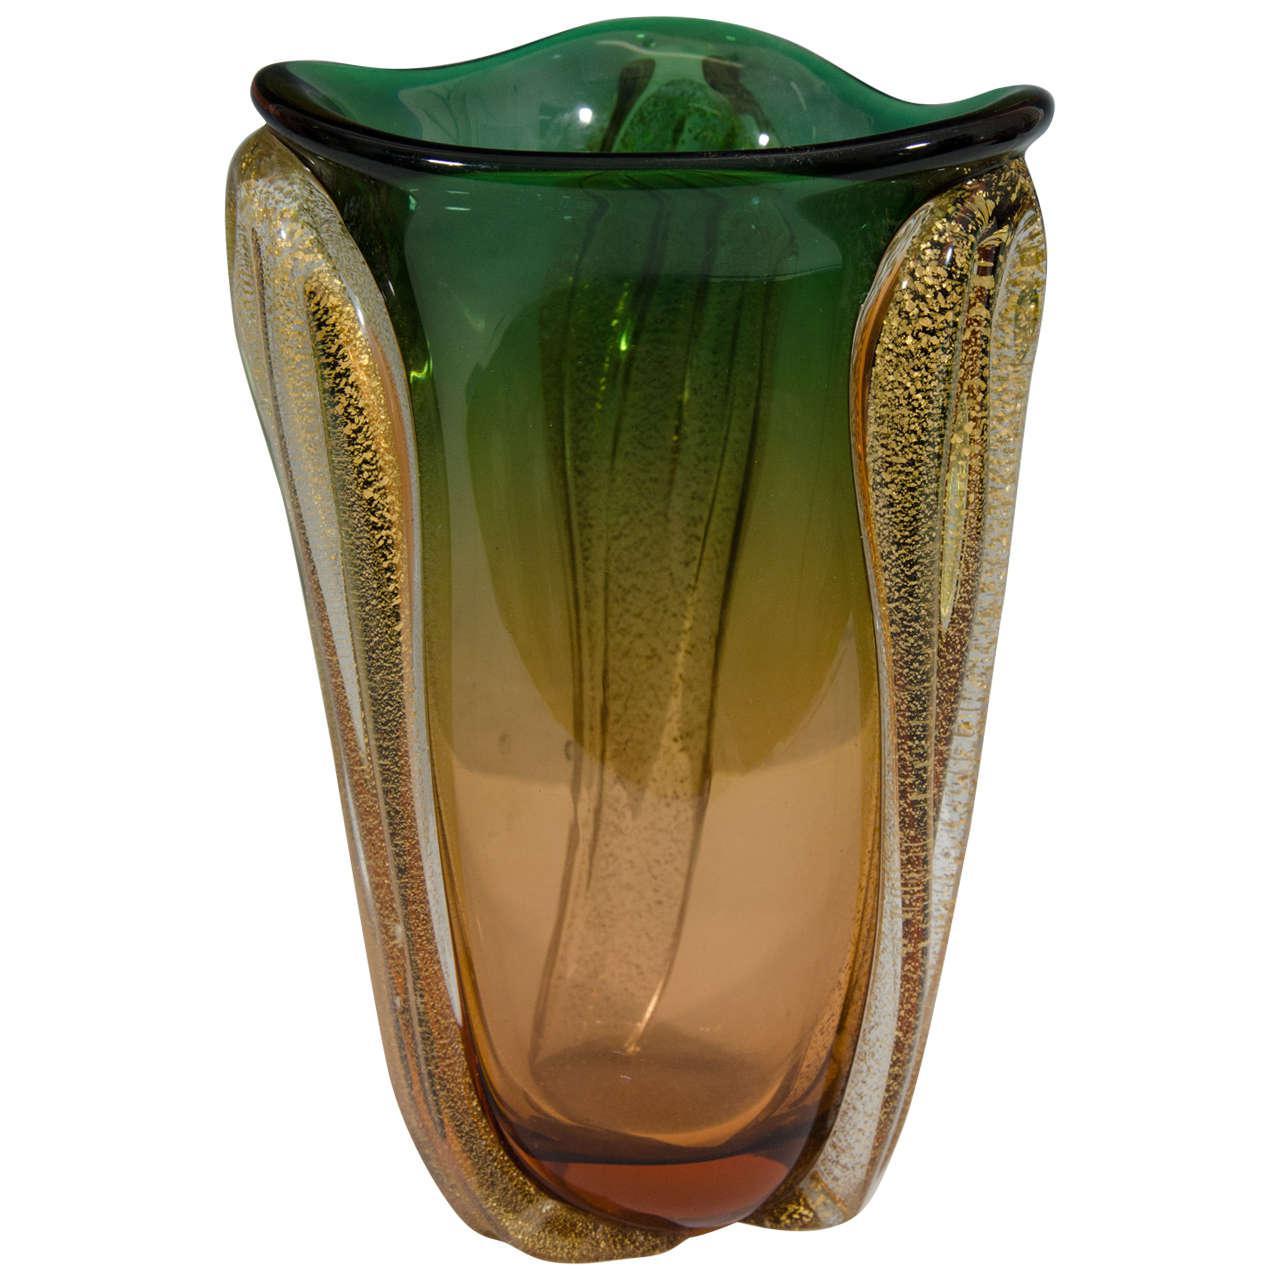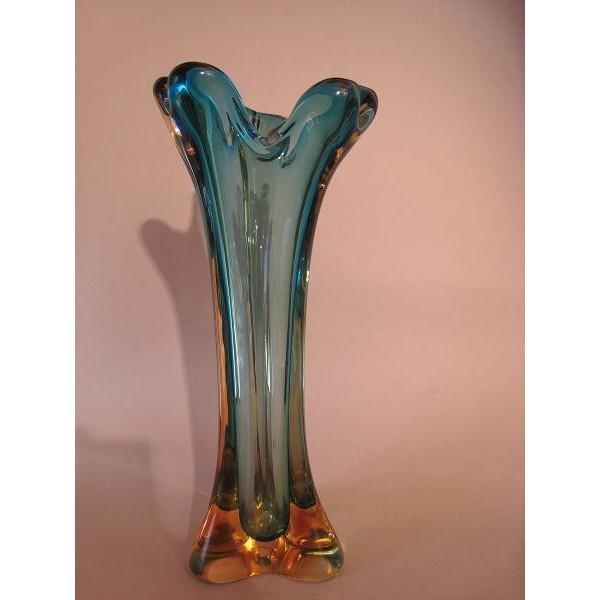The first image is the image on the left, the second image is the image on the right. For the images displayed, is the sentence "Each image shows a vase that flares at the top and has colored glass without a regular pattern." factually correct? Answer yes or no. Yes. The first image is the image on the left, the second image is the image on the right. Given the left and right images, does the statement "Both vases are at least party green." hold true? Answer yes or no. No. 